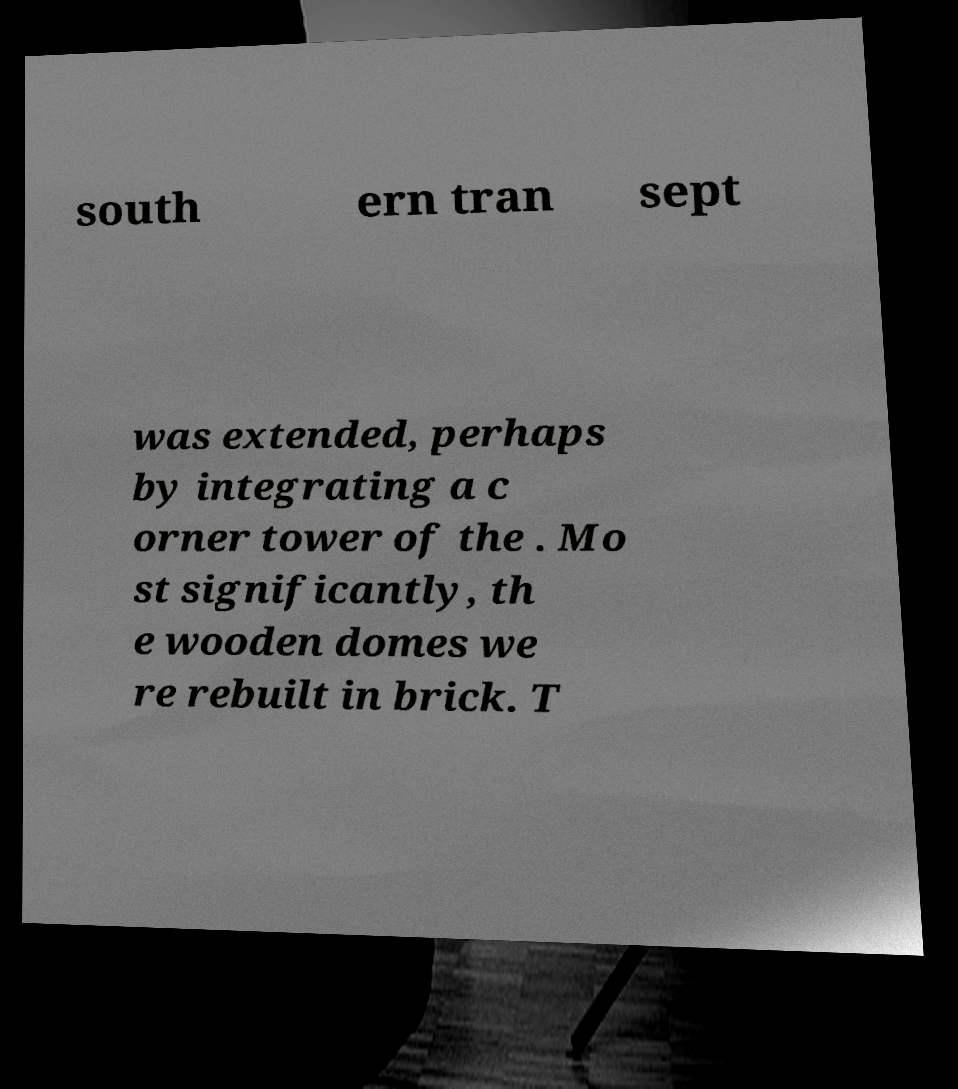Please identify and transcribe the text found in this image. south ern tran sept was extended, perhaps by integrating a c orner tower of the . Mo st significantly, th e wooden domes we re rebuilt in brick. T 